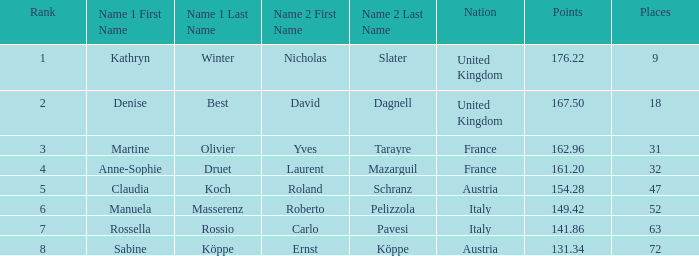Who has points larger than 167.5? Kathryn Winter / Nicholas Slater. 